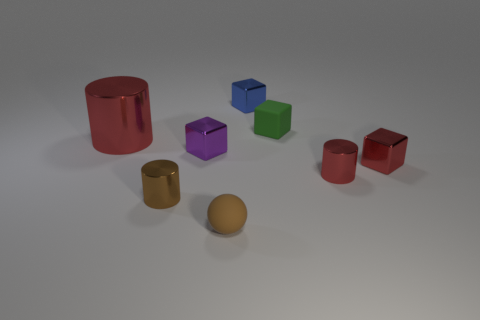There is a shiny block that is the same color as the large cylinder; what size is it?
Provide a short and direct response. Small. What number of tiny shiny objects are both behind the small red cylinder and left of the small brown ball?
Your response must be concise. 1. There is a tiny cylinder that is to the left of the tiny blue block; is its color the same as the small rubber ball that is right of the purple object?
Provide a succinct answer. Yes. There is a cube that is both on the left side of the matte block and in front of the tiny blue metallic block; what material is it made of?
Make the answer very short. Metal. Are there an equal number of small metallic cubes on the right side of the red cube and metallic objects that are to the right of the tiny green matte object?
Give a very brief answer. No. What is the material of the small purple cube?
Provide a short and direct response. Metal. There is a green thing that is behind the brown rubber thing; what is its material?
Make the answer very short. Rubber. Are there more tiny brown metallic things that are behind the matte sphere than blue cubes?
Your answer should be very brief. No. Is there a large cylinder that is left of the red metal cylinder that is behind the metal cylinder that is to the right of the small green thing?
Provide a succinct answer. No. There is a tiny purple block; are there any brown things on the left side of it?
Your answer should be very brief. Yes. 